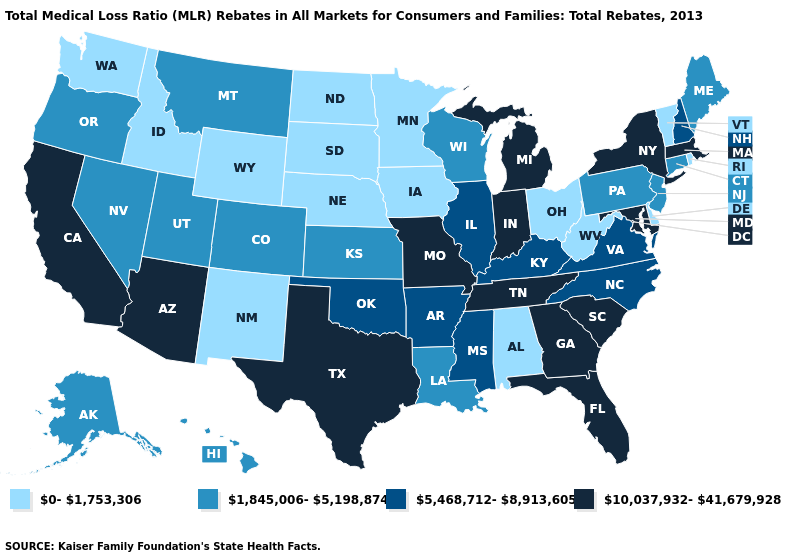What is the value of Iowa?
Answer briefly. 0-1,753,306. Name the states that have a value in the range 10,037,932-41,679,928?
Short answer required. Arizona, California, Florida, Georgia, Indiana, Maryland, Massachusetts, Michigan, Missouri, New York, South Carolina, Tennessee, Texas. Name the states that have a value in the range 10,037,932-41,679,928?
Concise answer only. Arizona, California, Florida, Georgia, Indiana, Maryland, Massachusetts, Michigan, Missouri, New York, South Carolina, Tennessee, Texas. What is the value of Florida?
Be succinct. 10,037,932-41,679,928. What is the value of Kansas?
Write a very short answer. 1,845,006-5,198,874. Does Alaska have the lowest value in the USA?
Be succinct. No. What is the highest value in the USA?
Keep it brief. 10,037,932-41,679,928. Does the first symbol in the legend represent the smallest category?
Give a very brief answer. Yes. Name the states that have a value in the range 5,468,712-8,913,605?
Be succinct. Arkansas, Illinois, Kentucky, Mississippi, New Hampshire, North Carolina, Oklahoma, Virginia. What is the lowest value in the USA?
Keep it brief. 0-1,753,306. Does South Carolina have the highest value in the South?
Short answer required. Yes. What is the lowest value in states that border California?
Quick response, please. 1,845,006-5,198,874. Which states have the lowest value in the West?
Quick response, please. Idaho, New Mexico, Washington, Wyoming. Among the states that border Connecticut , which have the highest value?
Concise answer only. Massachusetts, New York. Which states have the lowest value in the USA?
Keep it brief. Alabama, Delaware, Idaho, Iowa, Minnesota, Nebraska, New Mexico, North Dakota, Ohio, Rhode Island, South Dakota, Vermont, Washington, West Virginia, Wyoming. 